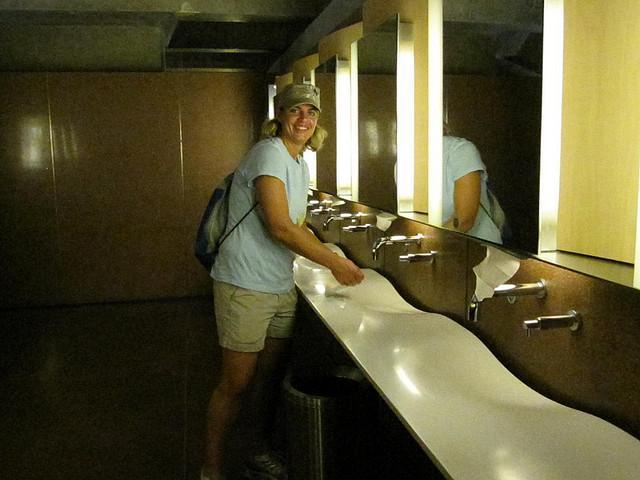How many sinks are being used?
Give a very brief answer. 1. How many sinks are there?
Give a very brief answer. 2. How many miniature horses are there in the field?
Give a very brief answer. 0. 